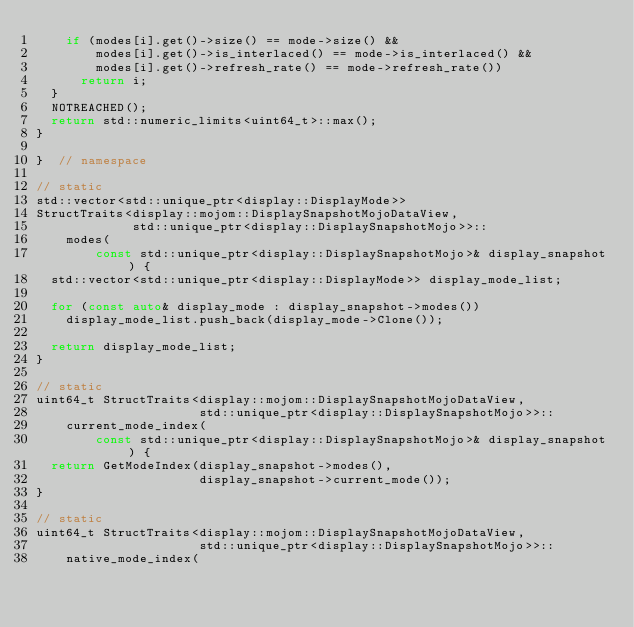Convert code to text. <code><loc_0><loc_0><loc_500><loc_500><_C++_>    if (modes[i].get()->size() == mode->size() &&
        modes[i].get()->is_interlaced() == mode->is_interlaced() &&
        modes[i].get()->refresh_rate() == mode->refresh_rate())
      return i;
  }
  NOTREACHED();
  return std::numeric_limits<uint64_t>::max();
}

}  // namespace

// static
std::vector<std::unique_ptr<display::DisplayMode>>
StructTraits<display::mojom::DisplaySnapshotMojoDataView,
             std::unique_ptr<display::DisplaySnapshotMojo>>::
    modes(
        const std::unique_ptr<display::DisplaySnapshotMojo>& display_snapshot) {
  std::vector<std::unique_ptr<display::DisplayMode>> display_mode_list;

  for (const auto& display_mode : display_snapshot->modes())
    display_mode_list.push_back(display_mode->Clone());

  return display_mode_list;
}

// static
uint64_t StructTraits<display::mojom::DisplaySnapshotMojoDataView,
                      std::unique_ptr<display::DisplaySnapshotMojo>>::
    current_mode_index(
        const std::unique_ptr<display::DisplaySnapshotMojo>& display_snapshot) {
  return GetModeIndex(display_snapshot->modes(),
                      display_snapshot->current_mode());
}

// static
uint64_t StructTraits<display::mojom::DisplaySnapshotMojoDataView,
                      std::unique_ptr<display::DisplaySnapshotMojo>>::
    native_mode_index(</code> 